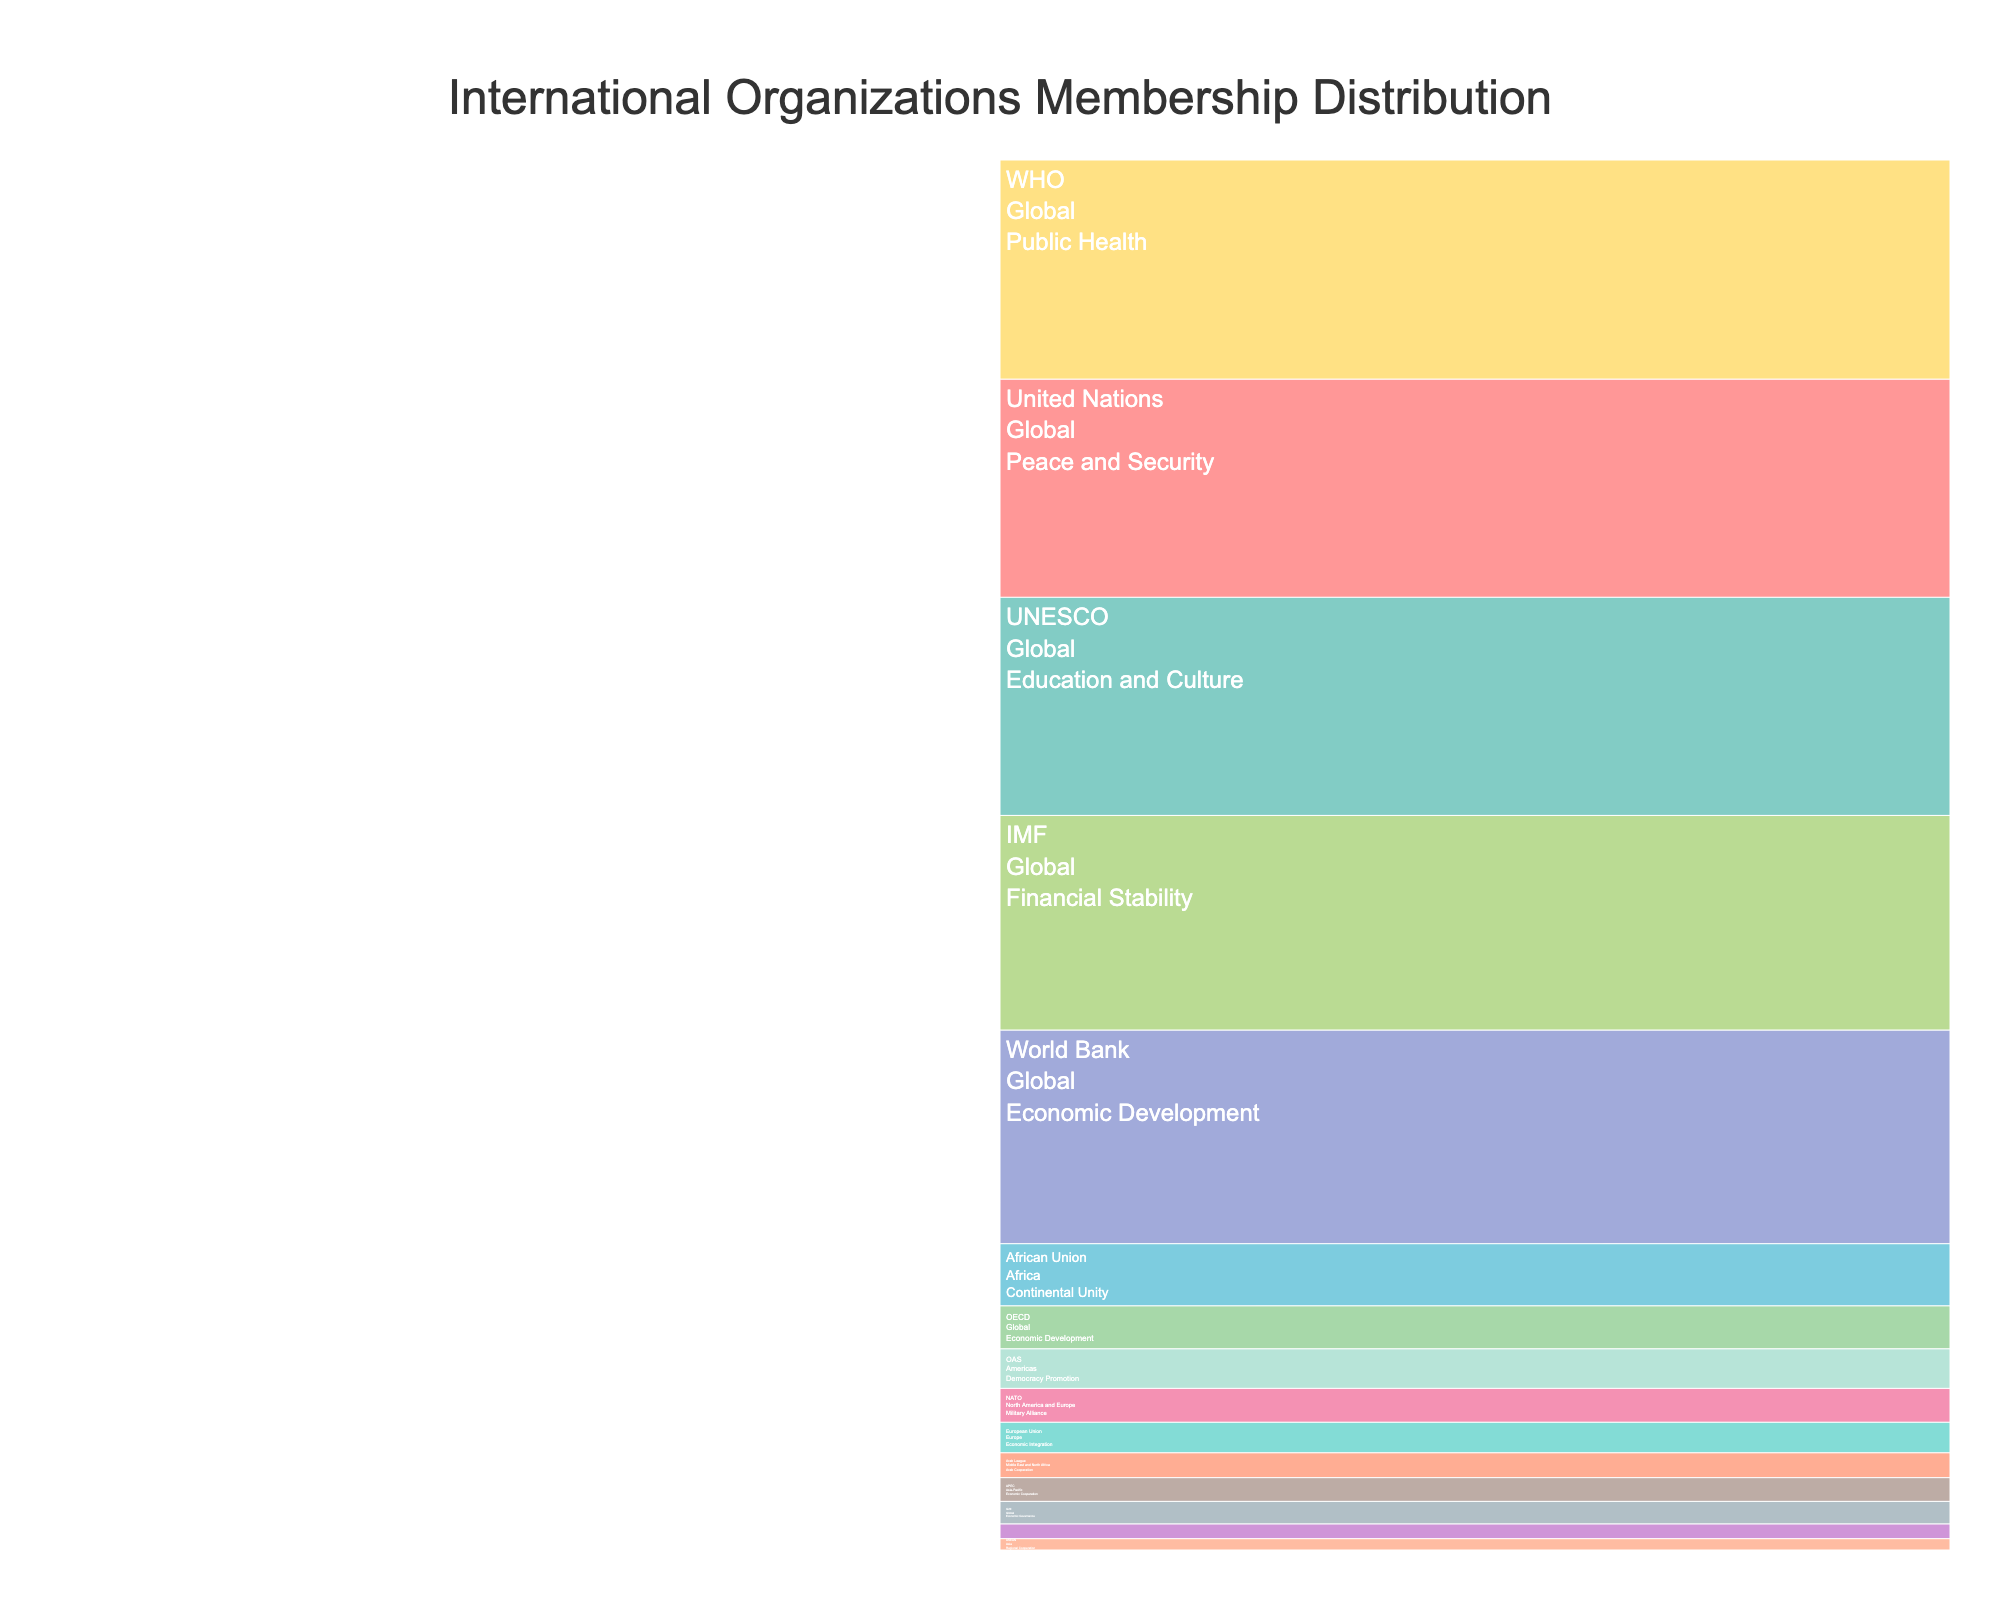What is the total number of United Nations (UN) members? The United Nations (UN) is listed under the 'Global' continent with a role in 'Peace and Security'. The figure shows the number of members is 193.
Answer: 193 Which organization has the highest number of members? By looking at the lengths and values next to each organization, the World Health Organization (WHO), listed under 'Global' with a role in 'Public Health', has the highest number at 194 members.
Answer: WHO How many continents are represented in the European Union? The chart shows the European Union (EU) is listed under the 'Europe' continent, so only one.
Answer: 1 What is the combined number of members in 'Global' organizations? To find the combined number of members for 'Global' organizations, sum the members listed under 'Global': 193 (UN) + 189 (World Bank) + 190 (IMF) + 194 (WHO) + 193 (UNESCO) + 13 (OPEC) + 20 (G20) + 38 (OECD) = 1030 members.
Answer: 1030 Which continents have the least number of organizations listed? By examining the chart, both Asia and the Americas have only one organization each: ASEAN and OAS, respectively.
Answer: Asia and Americas What roles are associated with 'Global' organizations? The icicle chart lists multiple roles under 'Global' organizations, including Peace and Security, Economic Development, Financial Stability, Public Health, Education and Culture, Oil Production, and Economic Governance.
Answer: Peace and Security, Economic Development, Financial Stability, Public Health, Education and Culture, Oil Production, Economic Governance Compare the number of members in NATO versus ASEAN. Which is larger? NATO has 30 members listed under 'North America and Europe, whereas ASEAN has 10 members under 'Asia'. Therefore, NATO has more members.
Answer: NATO What is the total number of organizations listed in the figure? Counting the unique organizations listed across all continents, there are 15 organizations in total.
Answer: 15 How many members does the African Union have compared to the Arab League? The African Union has 55 members listed under 'Africa' while the Arab League has 22 members listed under 'Middle East and North Africa'. The African Union has more members.
Answer: African Union Which organization focuses on 'Economic Development' under the 'Global' category? The organizations under 'Global' with a role in 'Economic Development' are the World Bank and the OECD.
Answer: World Bank and OECD 